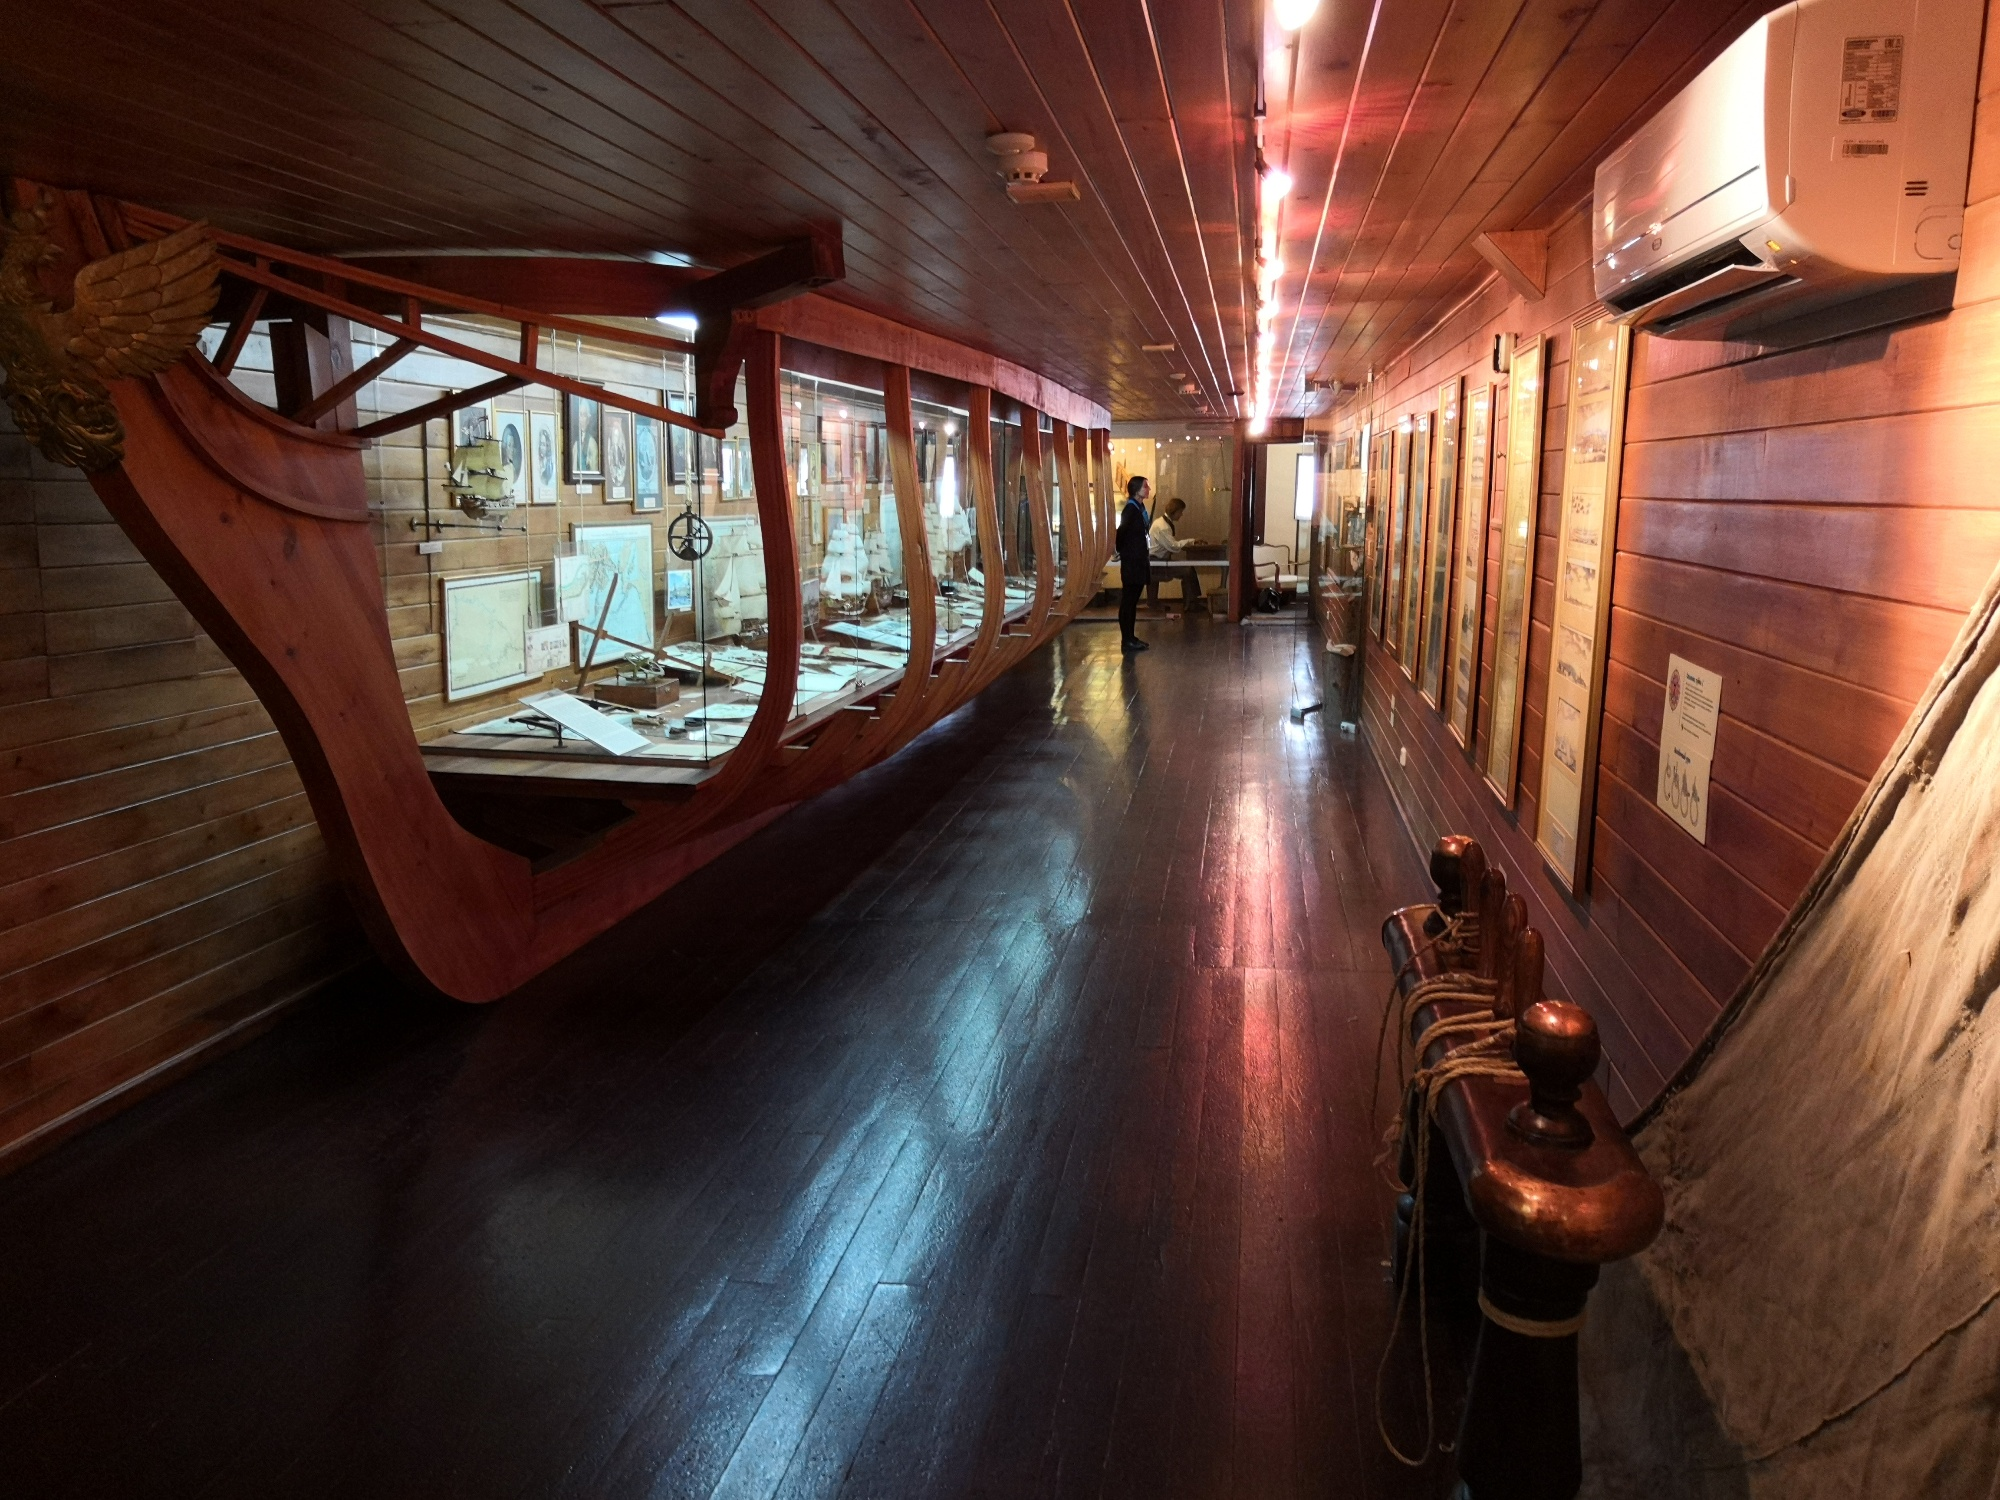Share a brief backstory about the museum. This museum, nestled in the heart of Funchal, Madeira, Portugal, was founded with a mission to preserve and celebrate the maritime history that shaped the world. It was established in collaboration with historians and maritime enthusiasts, who meticulously designed the exhibits to reflect the grandeur and significance of early exploration voyages. The centerpiece, a replica section of the Santa Maria, was crafted by skilled artisans using traditional shipbuilding techniques. The museum not only serves as a repository of historical artifacts but also hosts educational programs and events, bringing the rich maritime heritage to life for visitors of all ages. 